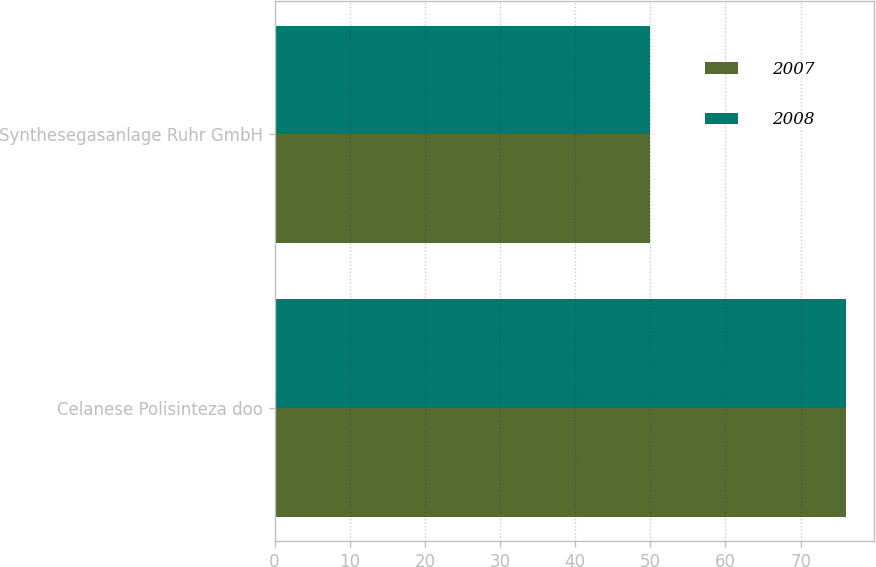Convert chart to OTSL. <chart><loc_0><loc_0><loc_500><loc_500><stacked_bar_chart><ecel><fcel>Celanese Polisinteza doo<fcel>Synthesegasanlage Ruhr GmbH<nl><fcel>2007<fcel>76<fcel>50<nl><fcel>2008<fcel>76<fcel>50<nl></chart> 